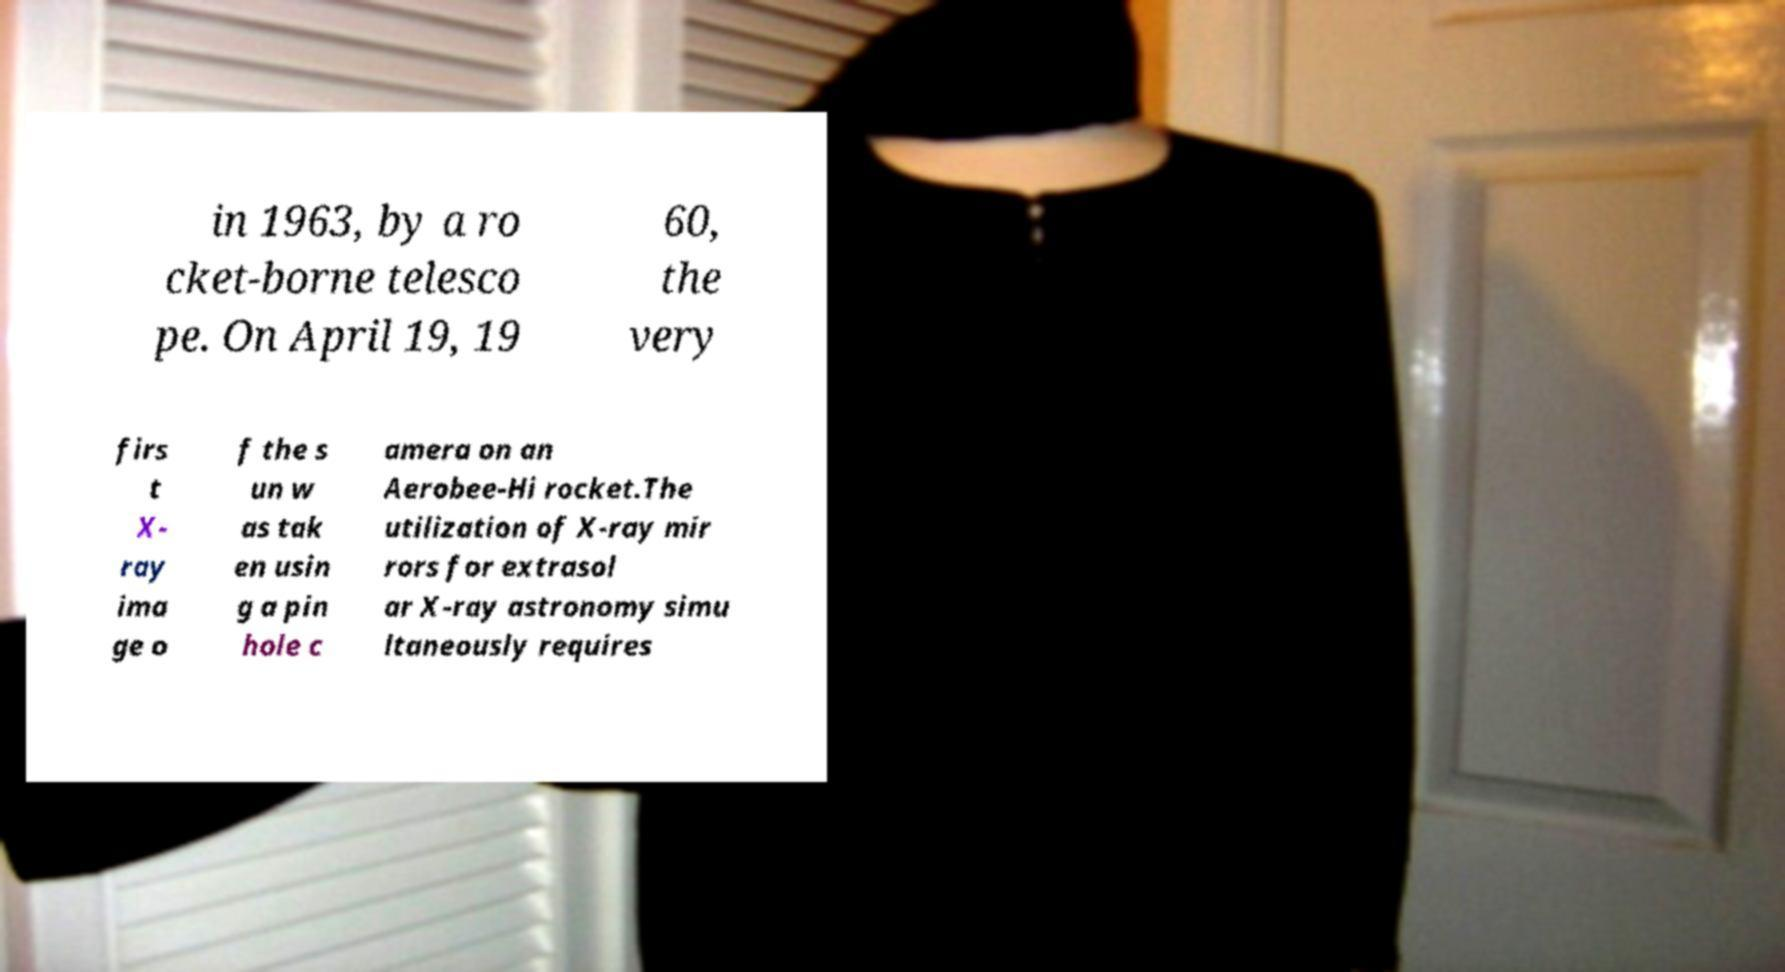Can you read and provide the text displayed in the image?This photo seems to have some interesting text. Can you extract and type it out for me? in 1963, by a ro cket-borne telesco pe. On April 19, 19 60, the very firs t X- ray ima ge o f the s un w as tak en usin g a pin hole c amera on an Aerobee-Hi rocket.The utilization of X-ray mir rors for extrasol ar X-ray astronomy simu ltaneously requires 